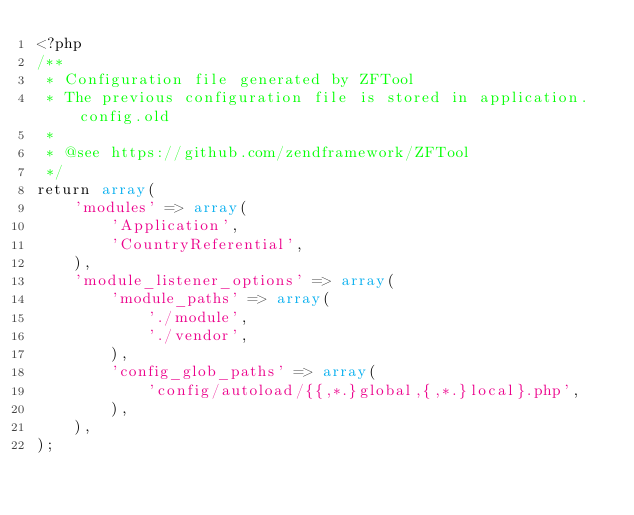Convert code to text. <code><loc_0><loc_0><loc_500><loc_500><_PHP_><?php
/**
 * Configuration file generated by ZFTool
 * The previous configuration file is stored in application.config.old
 *
 * @see https://github.com/zendframework/ZFTool
 */
return array(
    'modules' => array(
        'Application',
        'CountryReferential',
    ),
    'module_listener_options' => array(
        'module_paths' => array(
            './module',
            './vendor',
        ),
        'config_glob_paths' => array(
            'config/autoload/{{,*.}global,{,*.}local}.php',
        ),
    ),
);
</code> 